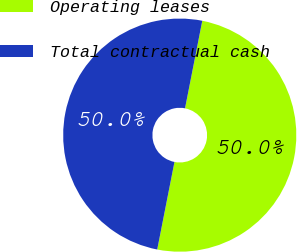Convert chart. <chart><loc_0><loc_0><loc_500><loc_500><pie_chart><fcel>Operating leases<fcel>Total contractual cash<nl><fcel>50.0%<fcel>50.0%<nl></chart> 